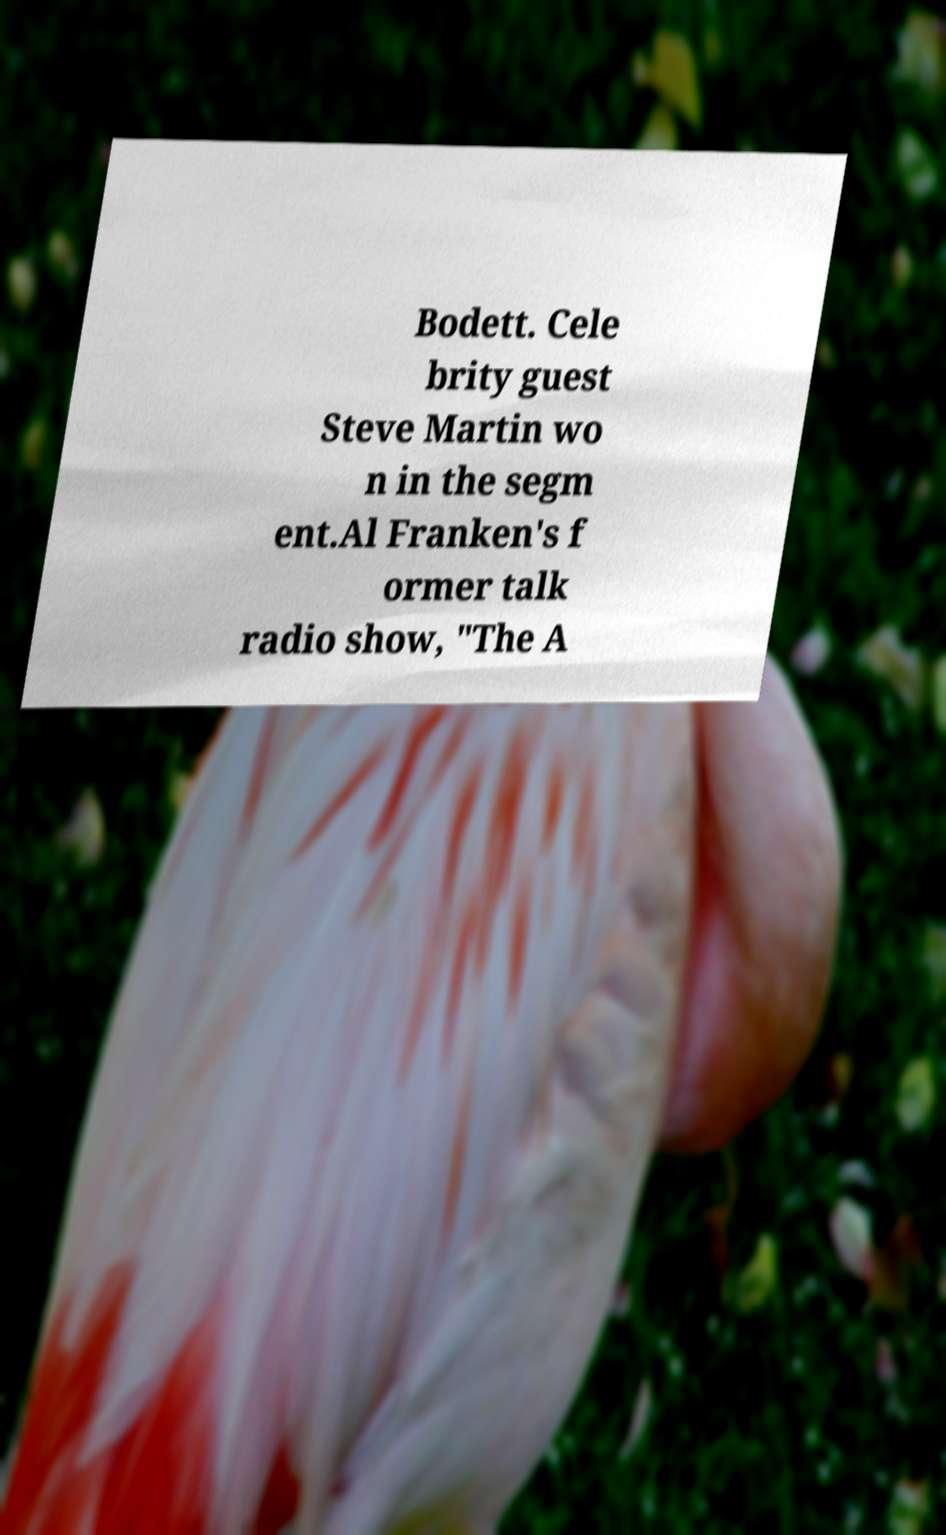There's text embedded in this image that I need extracted. Can you transcribe it verbatim? Bodett. Cele brity guest Steve Martin wo n in the segm ent.Al Franken's f ormer talk radio show, "The A 